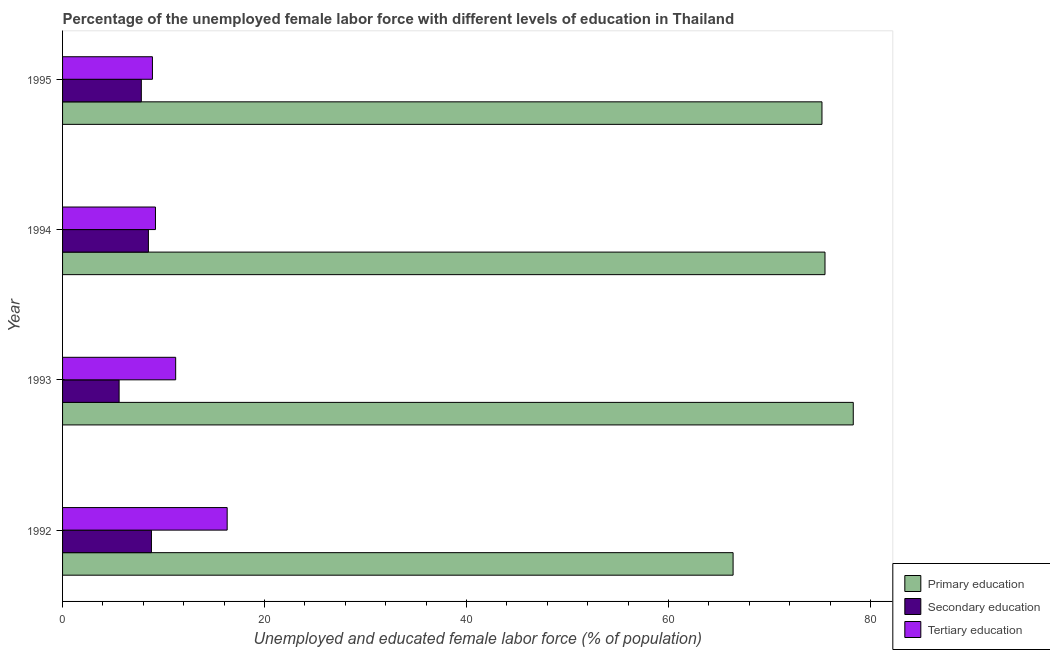How many groups of bars are there?
Provide a succinct answer. 4. Are the number of bars on each tick of the Y-axis equal?
Offer a terse response. Yes. How many bars are there on the 1st tick from the top?
Provide a succinct answer. 3. How many bars are there on the 4th tick from the bottom?
Keep it short and to the point. 3. What is the label of the 1st group of bars from the top?
Your answer should be compact. 1995. In how many cases, is the number of bars for a given year not equal to the number of legend labels?
Your response must be concise. 0. What is the percentage of female labor force who received secondary education in 1993?
Provide a short and direct response. 5.6. Across all years, what is the maximum percentage of female labor force who received tertiary education?
Ensure brevity in your answer.  16.3. Across all years, what is the minimum percentage of female labor force who received secondary education?
Offer a very short reply. 5.6. In which year was the percentage of female labor force who received tertiary education maximum?
Offer a very short reply. 1992. In which year was the percentage of female labor force who received tertiary education minimum?
Offer a terse response. 1995. What is the total percentage of female labor force who received secondary education in the graph?
Offer a very short reply. 30.7. What is the difference between the percentage of female labor force who received primary education in 1993 and that in 1995?
Offer a terse response. 3.1. What is the difference between the percentage of female labor force who received secondary education in 1995 and the percentage of female labor force who received primary education in 1993?
Make the answer very short. -70.5. In the year 1994, what is the difference between the percentage of female labor force who received secondary education and percentage of female labor force who received primary education?
Keep it short and to the point. -67. In how many years, is the percentage of female labor force who received primary education greater than 56 %?
Your answer should be very brief. 4. What is the ratio of the percentage of female labor force who received primary education in 1993 to that in 1995?
Keep it short and to the point. 1.04. Is the percentage of female labor force who received primary education in 1994 less than that in 1995?
Make the answer very short. No. Is the sum of the percentage of female labor force who received primary education in 1992 and 1994 greater than the maximum percentage of female labor force who received secondary education across all years?
Your answer should be compact. Yes. What does the 2nd bar from the top in 1995 represents?
Offer a terse response. Secondary education. What does the 3rd bar from the bottom in 1992 represents?
Ensure brevity in your answer.  Tertiary education. Are all the bars in the graph horizontal?
Offer a terse response. Yes. What is the difference between two consecutive major ticks on the X-axis?
Keep it short and to the point. 20. Does the graph contain any zero values?
Provide a succinct answer. No. Does the graph contain grids?
Provide a succinct answer. No. How many legend labels are there?
Give a very brief answer. 3. How are the legend labels stacked?
Your answer should be compact. Vertical. What is the title of the graph?
Make the answer very short. Percentage of the unemployed female labor force with different levels of education in Thailand. What is the label or title of the X-axis?
Ensure brevity in your answer.  Unemployed and educated female labor force (% of population). What is the label or title of the Y-axis?
Make the answer very short. Year. What is the Unemployed and educated female labor force (% of population) of Primary education in 1992?
Your answer should be compact. 66.4. What is the Unemployed and educated female labor force (% of population) of Secondary education in 1992?
Provide a succinct answer. 8.8. What is the Unemployed and educated female labor force (% of population) in Tertiary education in 1992?
Provide a succinct answer. 16.3. What is the Unemployed and educated female labor force (% of population) in Primary education in 1993?
Provide a short and direct response. 78.3. What is the Unemployed and educated female labor force (% of population) of Secondary education in 1993?
Ensure brevity in your answer.  5.6. What is the Unemployed and educated female labor force (% of population) in Tertiary education in 1993?
Your answer should be very brief. 11.2. What is the Unemployed and educated female labor force (% of population) of Primary education in 1994?
Your answer should be very brief. 75.5. What is the Unemployed and educated female labor force (% of population) in Tertiary education in 1994?
Provide a short and direct response. 9.2. What is the Unemployed and educated female labor force (% of population) of Primary education in 1995?
Keep it short and to the point. 75.2. What is the Unemployed and educated female labor force (% of population) in Secondary education in 1995?
Offer a very short reply. 7.8. What is the Unemployed and educated female labor force (% of population) in Tertiary education in 1995?
Offer a terse response. 8.9. Across all years, what is the maximum Unemployed and educated female labor force (% of population) in Primary education?
Offer a very short reply. 78.3. Across all years, what is the maximum Unemployed and educated female labor force (% of population) of Secondary education?
Keep it short and to the point. 8.8. Across all years, what is the maximum Unemployed and educated female labor force (% of population) in Tertiary education?
Give a very brief answer. 16.3. Across all years, what is the minimum Unemployed and educated female labor force (% of population) of Primary education?
Your response must be concise. 66.4. Across all years, what is the minimum Unemployed and educated female labor force (% of population) in Secondary education?
Provide a short and direct response. 5.6. Across all years, what is the minimum Unemployed and educated female labor force (% of population) in Tertiary education?
Your answer should be compact. 8.9. What is the total Unemployed and educated female labor force (% of population) in Primary education in the graph?
Your response must be concise. 295.4. What is the total Unemployed and educated female labor force (% of population) in Secondary education in the graph?
Your answer should be very brief. 30.7. What is the total Unemployed and educated female labor force (% of population) of Tertiary education in the graph?
Offer a very short reply. 45.6. What is the difference between the Unemployed and educated female labor force (% of population) in Primary education in 1992 and that in 1993?
Your answer should be compact. -11.9. What is the difference between the Unemployed and educated female labor force (% of population) in Secondary education in 1992 and that in 1993?
Your answer should be very brief. 3.2. What is the difference between the Unemployed and educated female labor force (% of population) in Tertiary education in 1992 and that in 1993?
Your response must be concise. 5.1. What is the difference between the Unemployed and educated female labor force (% of population) in Tertiary education in 1992 and that in 1994?
Keep it short and to the point. 7.1. What is the difference between the Unemployed and educated female labor force (% of population) of Primary education in 1993 and that in 1994?
Provide a succinct answer. 2.8. What is the difference between the Unemployed and educated female labor force (% of population) in Secondary education in 1993 and that in 1994?
Offer a very short reply. -2.9. What is the difference between the Unemployed and educated female labor force (% of population) in Secondary education in 1993 and that in 1995?
Your answer should be very brief. -2.2. What is the difference between the Unemployed and educated female labor force (% of population) in Primary education in 1994 and that in 1995?
Ensure brevity in your answer.  0.3. What is the difference between the Unemployed and educated female labor force (% of population) in Secondary education in 1994 and that in 1995?
Offer a terse response. 0.7. What is the difference between the Unemployed and educated female labor force (% of population) in Tertiary education in 1994 and that in 1995?
Ensure brevity in your answer.  0.3. What is the difference between the Unemployed and educated female labor force (% of population) in Primary education in 1992 and the Unemployed and educated female labor force (% of population) in Secondary education in 1993?
Your answer should be very brief. 60.8. What is the difference between the Unemployed and educated female labor force (% of population) in Primary education in 1992 and the Unemployed and educated female labor force (% of population) in Tertiary education in 1993?
Your response must be concise. 55.2. What is the difference between the Unemployed and educated female labor force (% of population) in Primary education in 1992 and the Unemployed and educated female labor force (% of population) in Secondary education in 1994?
Your answer should be compact. 57.9. What is the difference between the Unemployed and educated female labor force (% of population) in Primary education in 1992 and the Unemployed and educated female labor force (% of population) in Tertiary education in 1994?
Offer a terse response. 57.2. What is the difference between the Unemployed and educated female labor force (% of population) of Primary education in 1992 and the Unemployed and educated female labor force (% of population) of Secondary education in 1995?
Provide a short and direct response. 58.6. What is the difference between the Unemployed and educated female labor force (% of population) of Primary education in 1992 and the Unemployed and educated female labor force (% of population) of Tertiary education in 1995?
Keep it short and to the point. 57.5. What is the difference between the Unemployed and educated female labor force (% of population) of Primary education in 1993 and the Unemployed and educated female labor force (% of population) of Secondary education in 1994?
Provide a short and direct response. 69.8. What is the difference between the Unemployed and educated female labor force (% of population) in Primary education in 1993 and the Unemployed and educated female labor force (% of population) in Tertiary education in 1994?
Provide a short and direct response. 69.1. What is the difference between the Unemployed and educated female labor force (% of population) of Primary education in 1993 and the Unemployed and educated female labor force (% of population) of Secondary education in 1995?
Make the answer very short. 70.5. What is the difference between the Unemployed and educated female labor force (% of population) in Primary education in 1993 and the Unemployed and educated female labor force (% of population) in Tertiary education in 1995?
Provide a short and direct response. 69.4. What is the difference between the Unemployed and educated female labor force (% of population) of Secondary education in 1993 and the Unemployed and educated female labor force (% of population) of Tertiary education in 1995?
Ensure brevity in your answer.  -3.3. What is the difference between the Unemployed and educated female labor force (% of population) in Primary education in 1994 and the Unemployed and educated female labor force (% of population) in Secondary education in 1995?
Offer a terse response. 67.7. What is the difference between the Unemployed and educated female labor force (% of population) in Primary education in 1994 and the Unemployed and educated female labor force (% of population) in Tertiary education in 1995?
Your answer should be very brief. 66.6. What is the average Unemployed and educated female labor force (% of population) in Primary education per year?
Provide a short and direct response. 73.85. What is the average Unemployed and educated female labor force (% of population) in Secondary education per year?
Make the answer very short. 7.67. In the year 1992, what is the difference between the Unemployed and educated female labor force (% of population) in Primary education and Unemployed and educated female labor force (% of population) in Secondary education?
Offer a terse response. 57.6. In the year 1992, what is the difference between the Unemployed and educated female labor force (% of population) of Primary education and Unemployed and educated female labor force (% of population) of Tertiary education?
Your answer should be compact. 50.1. In the year 1992, what is the difference between the Unemployed and educated female labor force (% of population) of Secondary education and Unemployed and educated female labor force (% of population) of Tertiary education?
Make the answer very short. -7.5. In the year 1993, what is the difference between the Unemployed and educated female labor force (% of population) in Primary education and Unemployed and educated female labor force (% of population) in Secondary education?
Give a very brief answer. 72.7. In the year 1993, what is the difference between the Unemployed and educated female labor force (% of population) in Primary education and Unemployed and educated female labor force (% of population) in Tertiary education?
Your answer should be compact. 67.1. In the year 1994, what is the difference between the Unemployed and educated female labor force (% of population) of Primary education and Unemployed and educated female labor force (% of population) of Secondary education?
Offer a terse response. 67. In the year 1994, what is the difference between the Unemployed and educated female labor force (% of population) of Primary education and Unemployed and educated female labor force (% of population) of Tertiary education?
Keep it short and to the point. 66.3. In the year 1994, what is the difference between the Unemployed and educated female labor force (% of population) in Secondary education and Unemployed and educated female labor force (% of population) in Tertiary education?
Give a very brief answer. -0.7. In the year 1995, what is the difference between the Unemployed and educated female labor force (% of population) in Primary education and Unemployed and educated female labor force (% of population) in Secondary education?
Ensure brevity in your answer.  67.4. In the year 1995, what is the difference between the Unemployed and educated female labor force (% of population) of Primary education and Unemployed and educated female labor force (% of population) of Tertiary education?
Your answer should be compact. 66.3. In the year 1995, what is the difference between the Unemployed and educated female labor force (% of population) of Secondary education and Unemployed and educated female labor force (% of population) of Tertiary education?
Your answer should be very brief. -1.1. What is the ratio of the Unemployed and educated female labor force (% of population) of Primary education in 1992 to that in 1993?
Offer a terse response. 0.85. What is the ratio of the Unemployed and educated female labor force (% of population) of Secondary education in 1992 to that in 1993?
Provide a succinct answer. 1.57. What is the ratio of the Unemployed and educated female labor force (% of population) in Tertiary education in 1992 to that in 1993?
Make the answer very short. 1.46. What is the ratio of the Unemployed and educated female labor force (% of population) in Primary education in 1992 to that in 1994?
Make the answer very short. 0.88. What is the ratio of the Unemployed and educated female labor force (% of population) in Secondary education in 1992 to that in 1994?
Your answer should be compact. 1.04. What is the ratio of the Unemployed and educated female labor force (% of population) in Tertiary education in 1992 to that in 1994?
Provide a short and direct response. 1.77. What is the ratio of the Unemployed and educated female labor force (% of population) of Primary education in 1992 to that in 1995?
Provide a short and direct response. 0.88. What is the ratio of the Unemployed and educated female labor force (% of population) in Secondary education in 1992 to that in 1995?
Keep it short and to the point. 1.13. What is the ratio of the Unemployed and educated female labor force (% of population) in Tertiary education in 1992 to that in 1995?
Provide a succinct answer. 1.83. What is the ratio of the Unemployed and educated female labor force (% of population) of Primary education in 1993 to that in 1994?
Ensure brevity in your answer.  1.04. What is the ratio of the Unemployed and educated female labor force (% of population) in Secondary education in 1993 to that in 1994?
Provide a short and direct response. 0.66. What is the ratio of the Unemployed and educated female labor force (% of population) of Tertiary education in 1993 to that in 1994?
Your response must be concise. 1.22. What is the ratio of the Unemployed and educated female labor force (% of population) of Primary education in 1993 to that in 1995?
Your answer should be compact. 1.04. What is the ratio of the Unemployed and educated female labor force (% of population) of Secondary education in 1993 to that in 1995?
Make the answer very short. 0.72. What is the ratio of the Unemployed and educated female labor force (% of population) of Tertiary education in 1993 to that in 1995?
Make the answer very short. 1.26. What is the ratio of the Unemployed and educated female labor force (% of population) of Primary education in 1994 to that in 1995?
Make the answer very short. 1. What is the ratio of the Unemployed and educated female labor force (% of population) in Secondary education in 1994 to that in 1995?
Keep it short and to the point. 1.09. What is the ratio of the Unemployed and educated female labor force (% of population) of Tertiary education in 1994 to that in 1995?
Ensure brevity in your answer.  1.03. What is the difference between the highest and the lowest Unemployed and educated female labor force (% of population) in Primary education?
Provide a succinct answer. 11.9. What is the difference between the highest and the lowest Unemployed and educated female labor force (% of population) of Secondary education?
Make the answer very short. 3.2. 